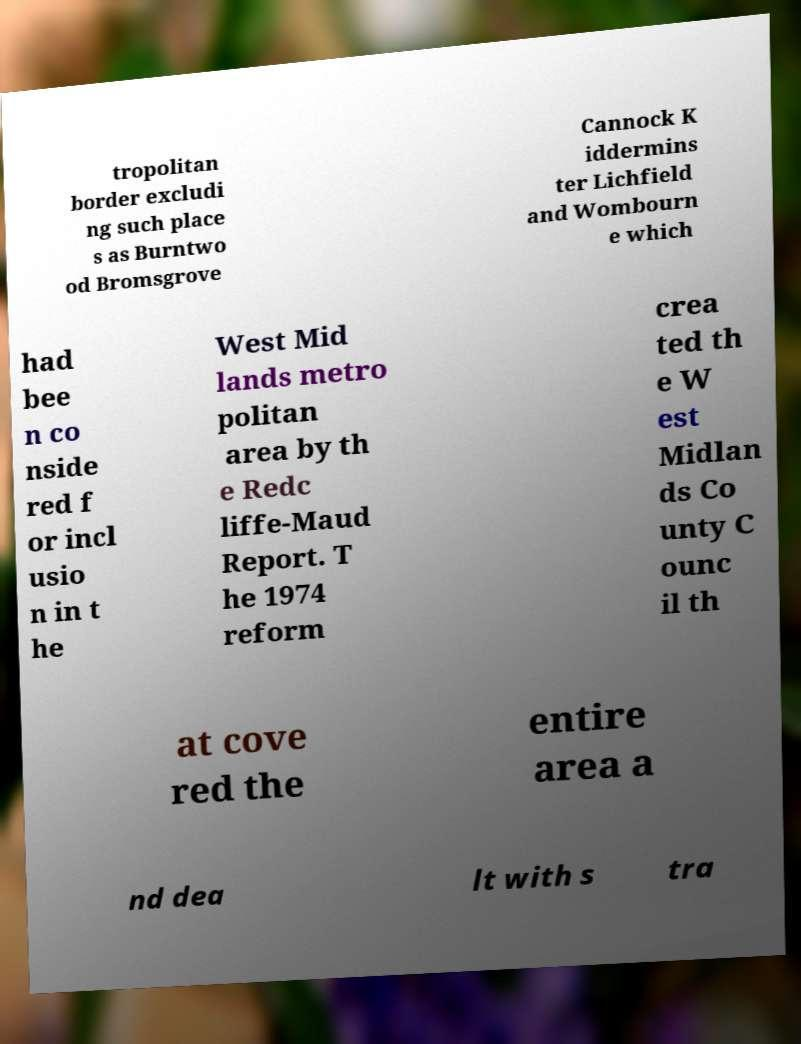I need the written content from this picture converted into text. Can you do that? tropolitan border excludi ng such place s as Burntwo od Bromsgrove Cannock K iddermins ter Lichfield and Wombourn e which had bee n co nside red f or incl usio n in t he West Mid lands metro politan area by th e Redc liffe-Maud Report. T he 1974 reform crea ted th e W est Midlan ds Co unty C ounc il th at cove red the entire area a nd dea lt with s tra 